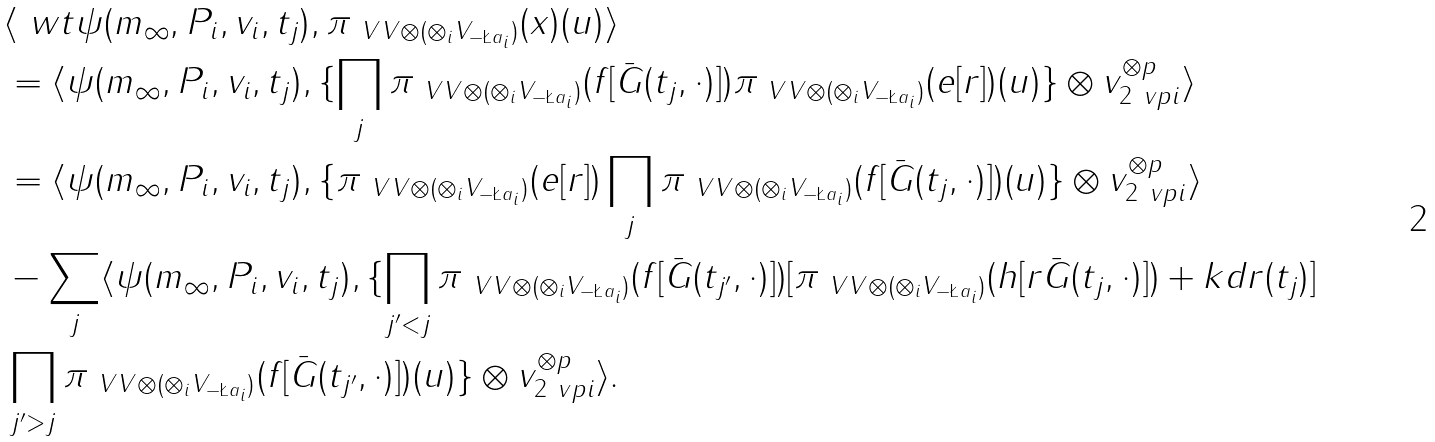Convert formula to latex. <formula><loc_0><loc_0><loc_500><loc_500>& \langle \ w t \psi ( m _ { \infty } , P _ { i } , v _ { i } , t _ { j } ) , \pi _ { \ V V \otimes ( \otimes _ { i } V _ { - \L a _ { i } } ) } ( x ) ( u ) \rangle \\ & = \langle \psi ( m _ { \infty } , P _ { i } , v _ { i } , t _ { j } ) , \{ \prod _ { j } \pi _ { \ V V \otimes ( \otimes _ { i } V _ { - \L a _ { i } } ) } ( f [ \bar { G } ( t _ { j } , \cdot ) ] ) \pi _ { \ V V \otimes ( \otimes _ { i } V _ { - \L a _ { i } } ) } ( e [ r ] ) ( u ) \} \otimes v _ { 2 \ v p i } ^ { \otimes p } \rangle \\ & = \langle \psi ( m _ { \infty } , P _ { i } , v _ { i } , t _ { j } ) , \{ \pi _ { \ V V \otimes ( \otimes _ { i } V _ { - \L a _ { i } } ) } ( e [ r ] ) \prod _ { j } \pi _ { \ V V \otimes ( \otimes _ { i } V _ { - \L a _ { i } } ) } ( f [ \bar { G } ( t _ { j } , \cdot ) ] ) ( u ) \} \otimes v _ { 2 \ v p i } ^ { \otimes p } \rangle \\ & - \sum _ { j } \langle \psi ( m _ { \infty } , P _ { i } , v _ { i } , t _ { j } ) , \{ \prod _ { j ^ { \prime } < j } \pi _ { \ V V \otimes ( \otimes _ { i } V _ { - \L a _ { i } } ) } ( f [ \bar { G } ( t _ { j ^ { \prime } } , \cdot ) ] ) [ \pi _ { \ V V \otimes ( \otimes _ { i } V _ { - \L a _ { i } } ) } ( h [ r \bar { G } ( t _ { j } , \cdot ) ] ) + k d r ( t _ { j } ) ] \\ & \prod _ { j ^ { \prime } > j } \pi _ { \ V V \otimes ( \otimes _ { i } V _ { - \L a _ { i } } ) } ( f [ \bar { G } ( t _ { j ^ { \prime } } , \cdot ) ] ) ( u ) \} \otimes v _ { 2 \ v p i } ^ { \otimes p } \rangle .</formula> 